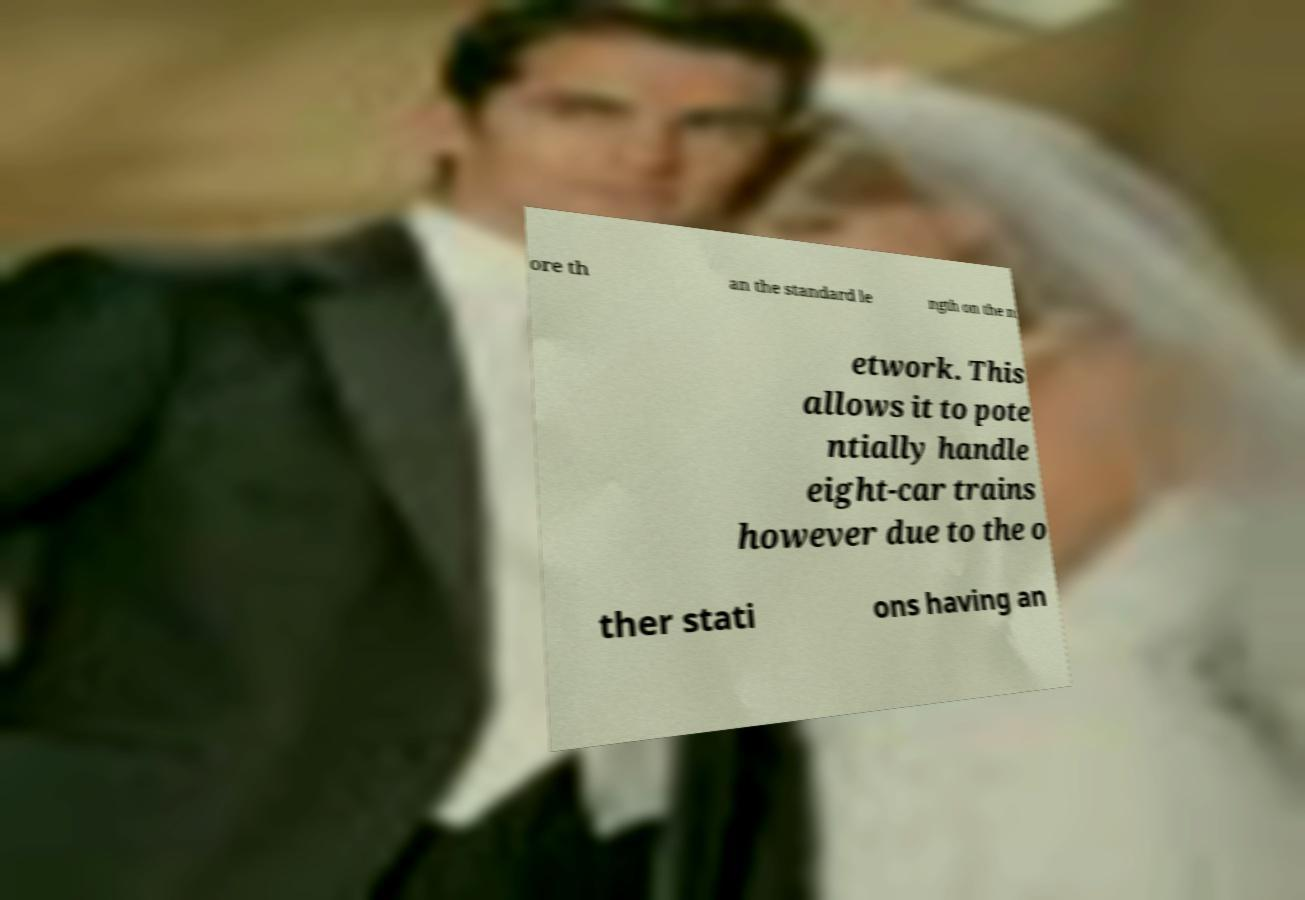I need the written content from this picture converted into text. Can you do that? ore th an the standard le ngth on the n etwork. This allows it to pote ntially handle eight-car trains however due to the o ther stati ons having an 